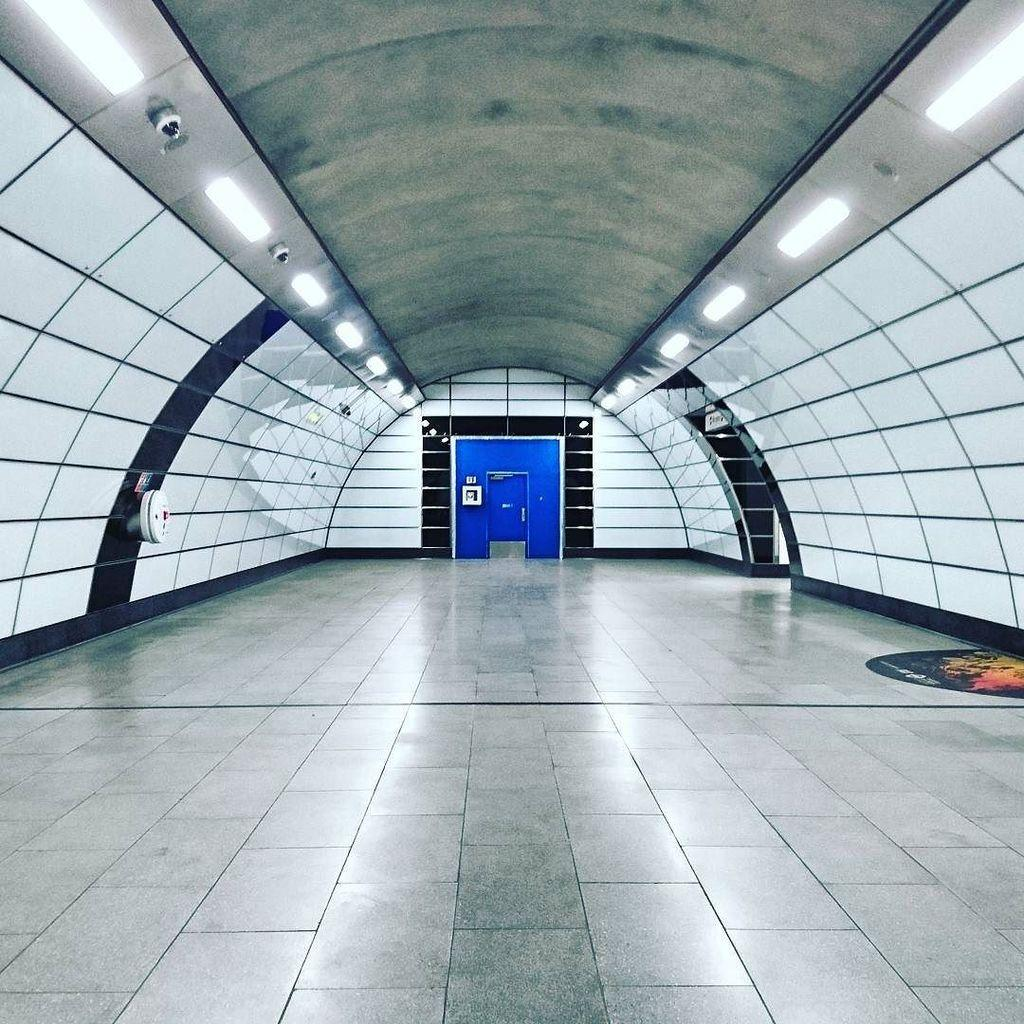What is located in the center of the image? There is a door in the center of the image. Where are the lights positioned in the image? There are lights on both the right and left sides of the image. What can be seen on the right side of the image? There is a wall and lights on the right side of the image. What is present on the left side of the image? There is a wall and lights on the left side of the image. What type of jeans can be seen in the image? There are no jeans present in the image. Is there any blood visible in the image? There is no blood visible in the image. 